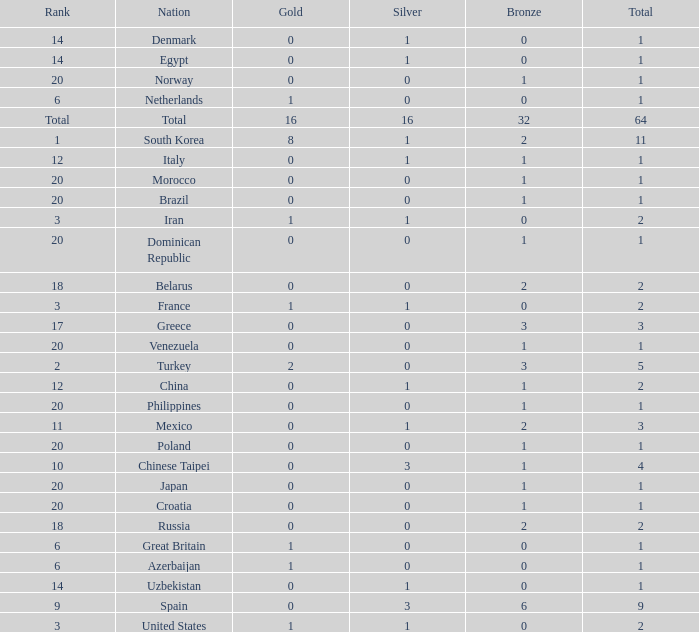What is the average number of bronze medals of the Philippines, which has more than 0 gold? None. 